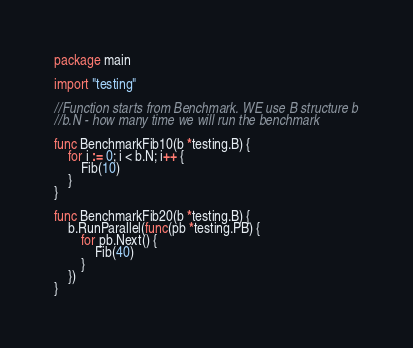Convert code to text. <code><loc_0><loc_0><loc_500><loc_500><_Go_>package main

import "testing"

//Function starts from Benchmark. WE use B structure b
//b.N - how many time we will run the benchmark

func BenchmarkFib10(b *testing.B) {
	for i := 0; i < b.N; i++ {
		Fib(10)
	}
}

func BenchmarkFib20(b *testing.B) {
	b.RunParallel(func(pb *testing.PB) {
		for pb.Next() {
			Fib(40)
		}
	})
}
</code> 